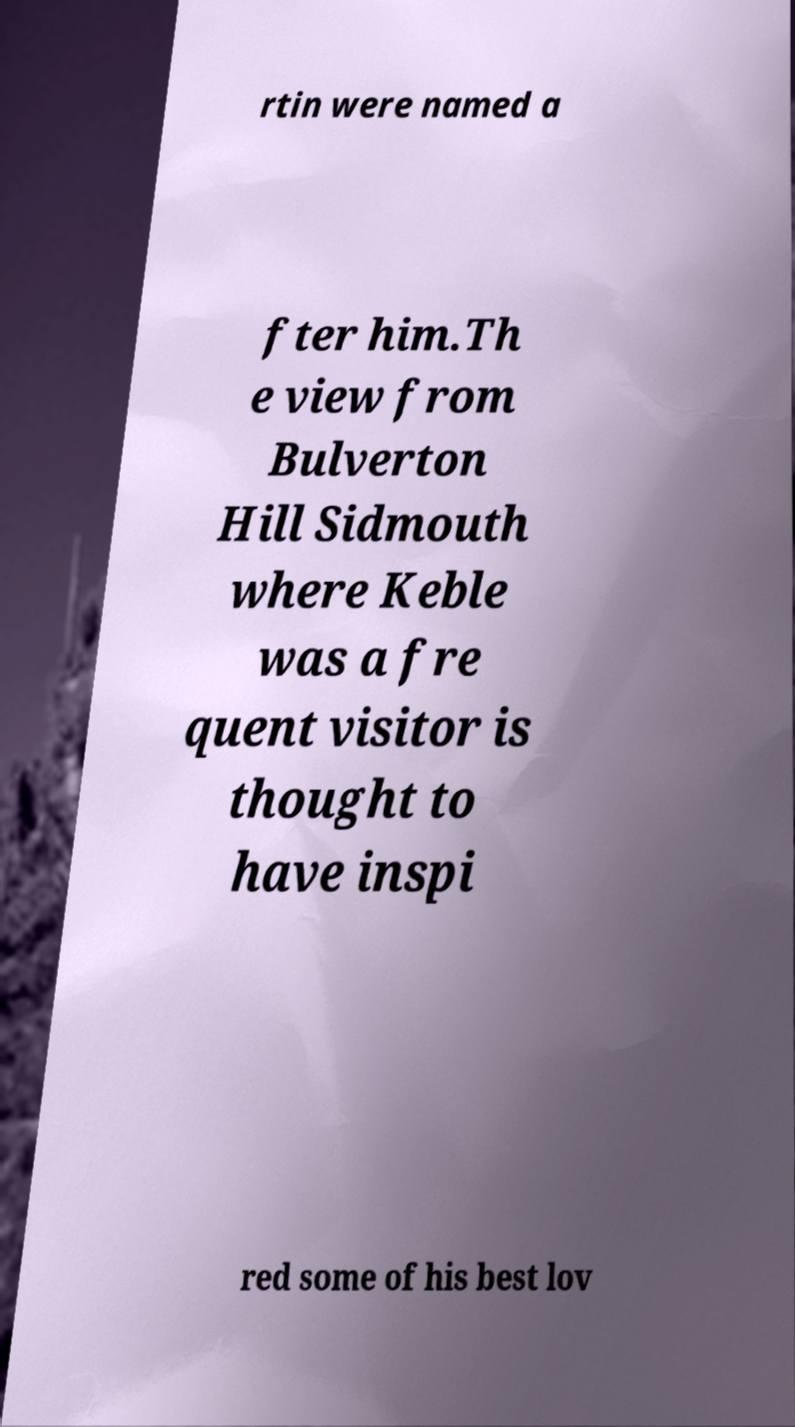Please identify and transcribe the text found in this image. rtin were named a fter him.Th e view from Bulverton Hill Sidmouth where Keble was a fre quent visitor is thought to have inspi red some of his best lov 